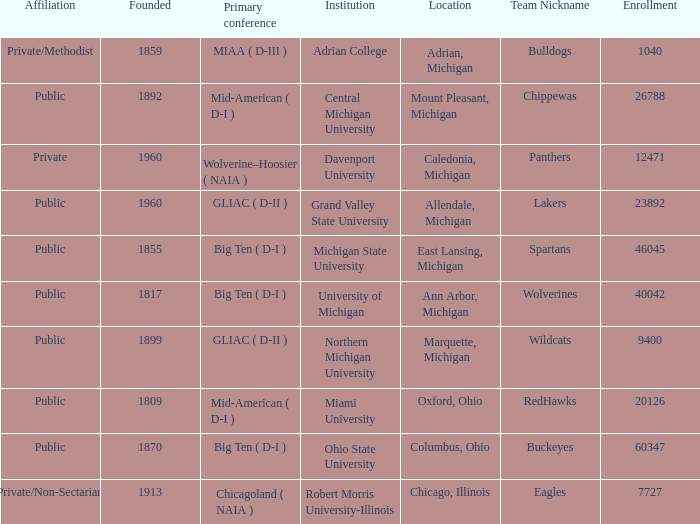What is the enrollment for the Redhawks? 1.0. 